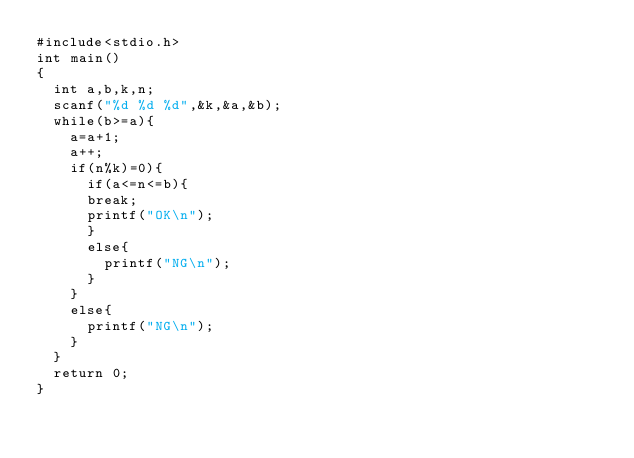<code> <loc_0><loc_0><loc_500><loc_500><_C_>#include<stdio.h>
int main()
{
  int a,b,k,n;
  scanf("%d %d %d",&k,&a,&b);
  while(b>=a){
    a=a+1;
    a++;
    if(n%k)=0){
      if(a<=n<=b){
      break;
      printf("OK\n");
      }
      else{
        printf("NG\n");
      }
    }
    else{
      printf("NG\n");
    }
  }
  return 0;
}</code> 